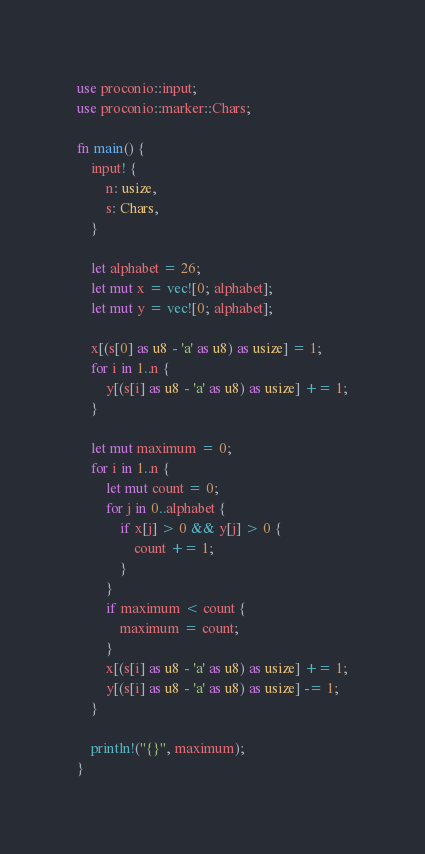Convert code to text. <code><loc_0><loc_0><loc_500><loc_500><_Rust_>use proconio::input;
use proconio::marker::Chars;

fn main() {
    input! {
        n: usize,
        s: Chars,
    }

    let alphabet = 26;
    let mut x = vec![0; alphabet];
    let mut y = vec![0; alphabet];

    x[(s[0] as u8 - 'a' as u8) as usize] = 1;
    for i in 1..n {
        y[(s[i] as u8 - 'a' as u8) as usize] += 1;
    }

    let mut maximum = 0;
    for i in 1..n {
        let mut count = 0;
        for j in 0..alphabet {
            if x[j] > 0 && y[j] > 0 {
                count += 1;
            }
        }
        if maximum < count {
            maximum = count;
        }
        x[(s[i] as u8 - 'a' as u8) as usize] += 1;
        y[(s[i] as u8 - 'a' as u8) as usize] -= 1;
    }

    println!("{}", maximum);
}</code> 